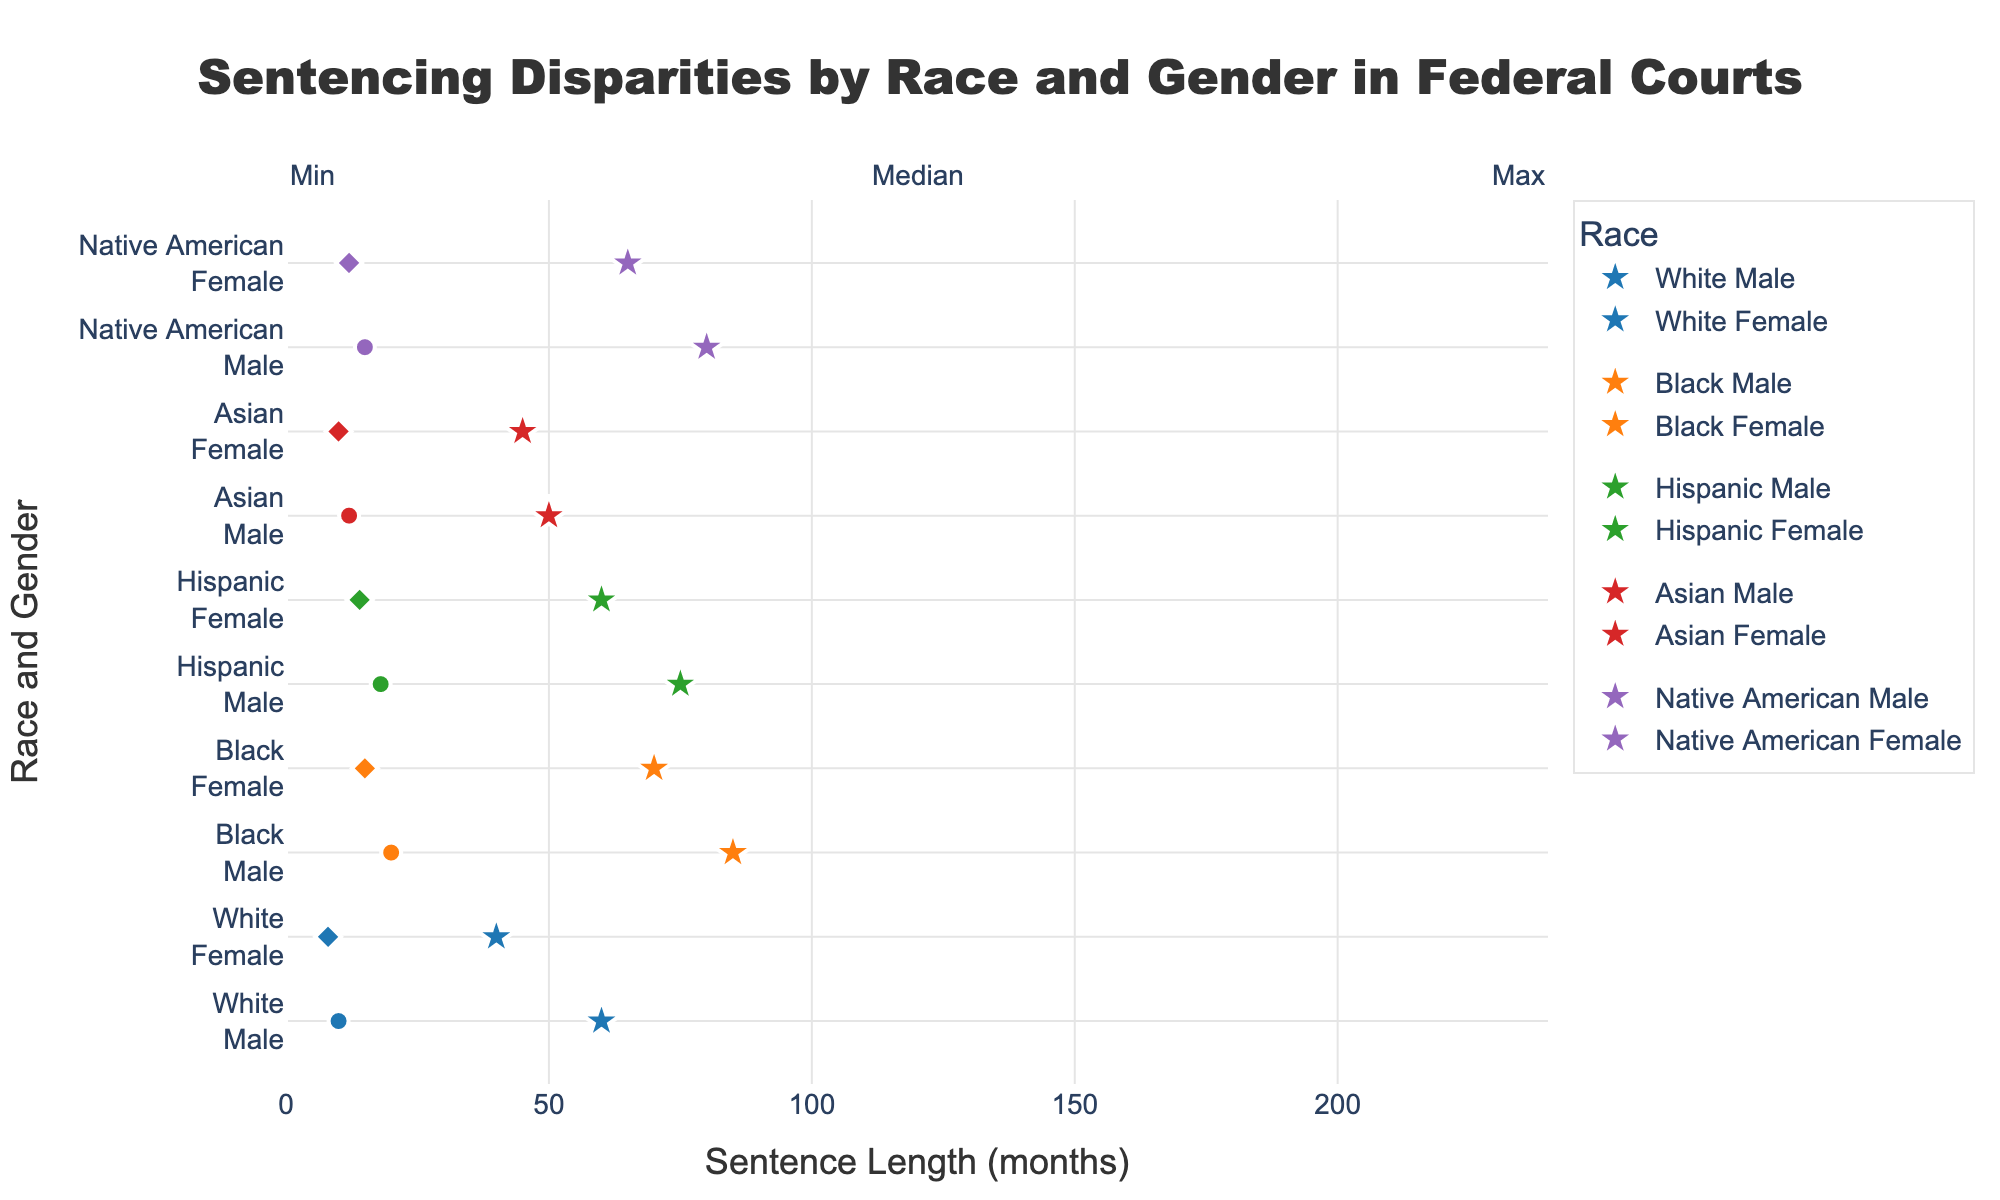Which group has the highest maximum sentence? To find the group with the highest maximum sentence, look at the maximum points for each race and gender combination and identify the highest value. Black Males have the highest maximum sentence at 220 months.
Answer: Black Males What is the median sentence length for Hispanic females? Locate the Hispanic Female group and check the median value, which is represented by the star symbol. The median sentence length for Hispanic females is 60 months.
Answer: 60 months Which gender generally receives longer sentences within the same race? Compare the maximum sentence lengths for males and females within each race. Across all races (White, Black, Hispanic, Asian, and Native American), males generally receive longer sentences than females.
Answer: Males What is the range of sentences for Native American Females? The range is the difference between the maximum and minimum sentences. For Native American Females, the maximum is 180 months and the minimum is 12 months. Therefore, the range is 180 - 12 = 168 months.
Answer: 168 months How do the median sentences of Black Males and Black Females compare? Find the median values for Black Males and Black Females represented by star symbols. Black Males have a median of 85 months, whereas Black Females have a median of 70 months. Thus, Black Males have a higher median sentence.
Answer: Black Males have a higher median What is the difference between the maximum sentence of White Males and White Females? Identify the maximum points for White Males and White Females. The maximum for White Males is 180 months and for White Females is 150 months. The difference is 180 - 150 = 30 months.
Answer: 30 months Which group has the smallest minimum sentence? Determine the minimum sentence values across all groups and compare them. White Females have the smallest minimum sentence at 8 months.
Answer: White Females What is the average of the median sentences for all males? Sum the median sentences for all male groups and divide by the number of male groups. The medians are: White (60), Black (85), Hispanic (75), Asian (50), Native American (80). The average is (60 + 85 + 75 + 50 + 80) / 5 = 70 months.
Answer: 70 months How do the sentencing ranges of Hispanic Males and Asian Males differ? The range is the difference between maximum and minimum values. For Hispanic Males: 200 - 18 = 182 months. For Asian Males: 160 - 12 = 148 months. Hispanic Males have a wider sentencing range.
Answer: Hispanic Males have a wider range 